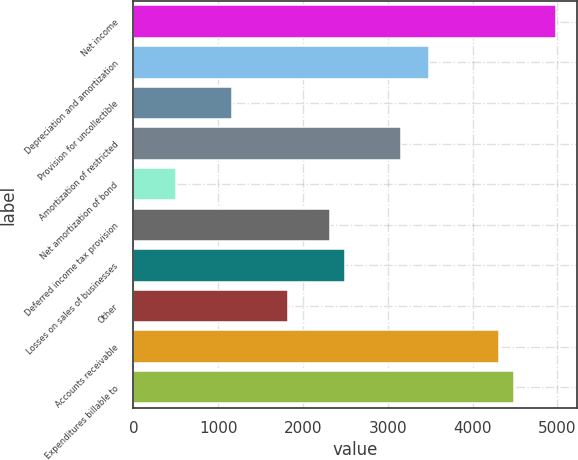Convert chart to OTSL. <chart><loc_0><loc_0><loc_500><loc_500><bar_chart><fcel>Net income<fcel>Depreciation and amortization<fcel>Provision for uncollectible<fcel>Amortization of restricted<fcel>Net amortization of bond<fcel>Deferred income tax provision<fcel>Losses on sales of businesses<fcel>Other<fcel>Accounts receivable<fcel>Expenditures billable to<nl><fcel>4981.6<fcel>3487.15<fcel>1162.45<fcel>3155.05<fcel>498.25<fcel>2324.8<fcel>2490.85<fcel>1826.65<fcel>4317.4<fcel>4483.45<nl></chart> 